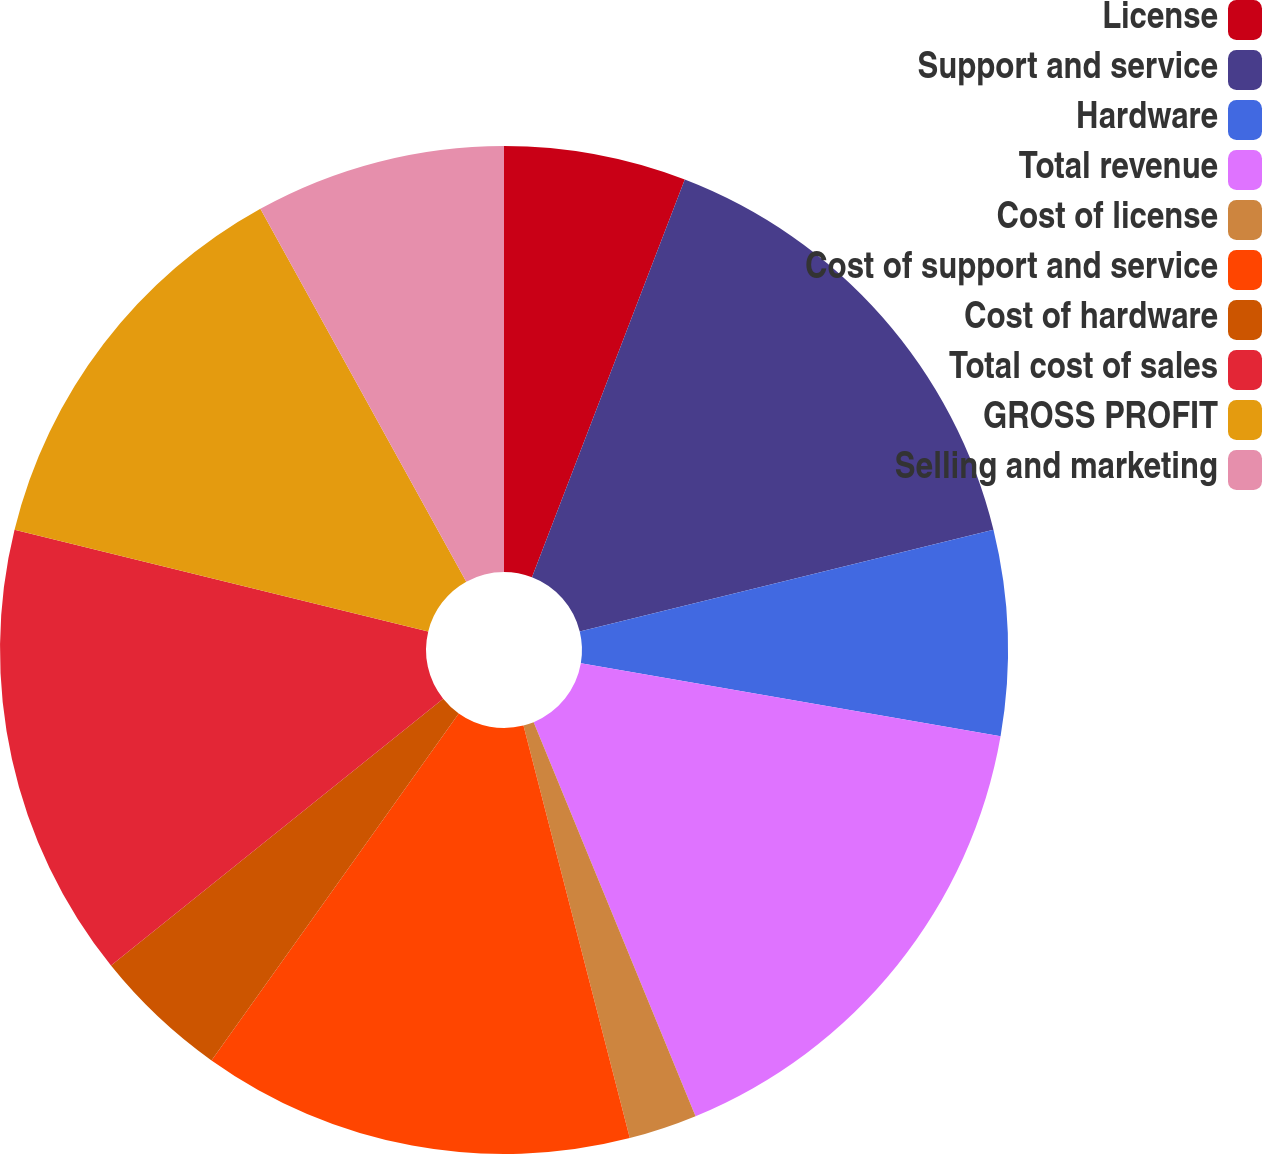Convert chart. <chart><loc_0><loc_0><loc_500><loc_500><pie_chart><fcel>License<fcel>Support and service<fcel>Hardware<fcel>Total revenue<fcel>Cost of license<fcel>Cost of support and service<fcel>Cost of hardware<fcel>Total cost of sales<fcel>GROSS PROFIT<fcel>Selling and marketing<nl><fcel>5.84%<fcel>15.33%<fcel>6.57%<fcel>16.06%<fcel>2.19%<fcel>13.87%<fcel>4.38%<fcel>14.6%<fcel>13.14%<fcel>8.03%<nl></chart> 